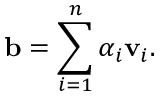<formula> <loc_0><loc_0><loc_500><loc_500>b = \sum _ { i = 1 } ^ { n } \alpha _ { i } v _ { i } .</formula> 